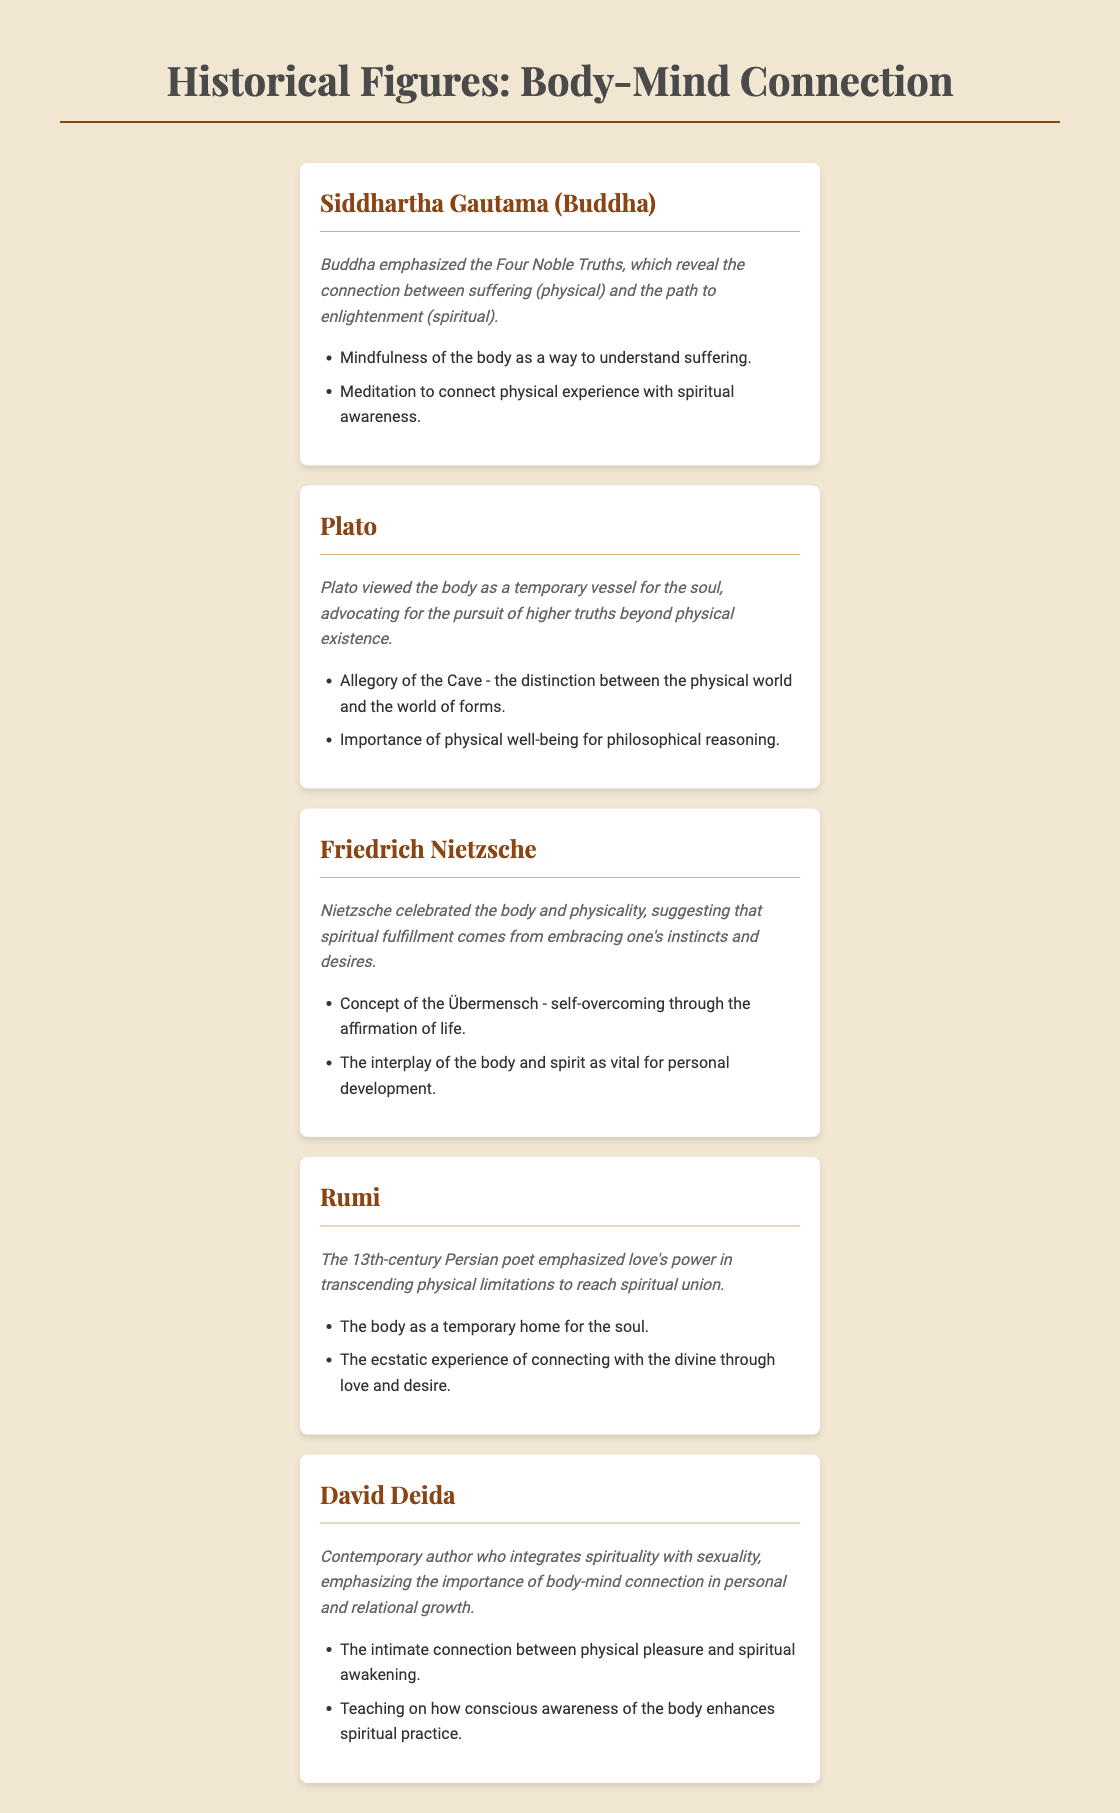What is emphasized by Siddhartha Gautama? Siddhartha Gautama emphasized the Four Noble Truths, which reveal the connection between suffering and the path to enlightenment.
Answer: Four Noble Truths What did Plato advocate for? Plato advocated for the pursuit of higher truths beyond physical existence.
Answer: Higher truths What does Nietzsche's concept of the Übermensch entail? Nietzsche's concept of the Übermensch entails self-overcoming through the affirmation of life.
Answer: Self-overcoming In what century did Rumi write? Rumi wrote in the 13th century.
Answer: 13th century What is David Deida known for? David Deida is known for integrating spirituality with sexuality.
Answer: Integrating spirituality with sexuality What is the relationship between the body and spirituality according to Friedrich Nietzsche? Nietzsche suggested that spiritual fulfillment comes from embracing one's instincts and desires.
Answer: Embracing instincts and desires What power does Rumi emphasize in transcending physical limitations? Rumi emphasizes love's power in transcending physical limitations.
Answer: Love's power Which philosophical idea involves the distinction between the physical world and the world of forms? The philosophical idea involving the distinction between the physical world and the world of forms is the Allegory of the Cave.
Answer: Allegory of the Cave What is the importance of physical well-being according to Plato? The importance of physical well-being according to Plato is for philosophical reasoning.
Answer: Philosophical reasoning 